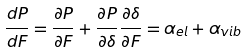<formula> <loc_0><loc_0><loc_500><loc_500>\frac { d P } { d F } = \frac { \partial P } { \partial F } + \frac { \partial P } { \partial \delta } \frac { \partial \delta } { \partial F } = \alpha _ { e l } + \alpha _ { v i b }</formula> 